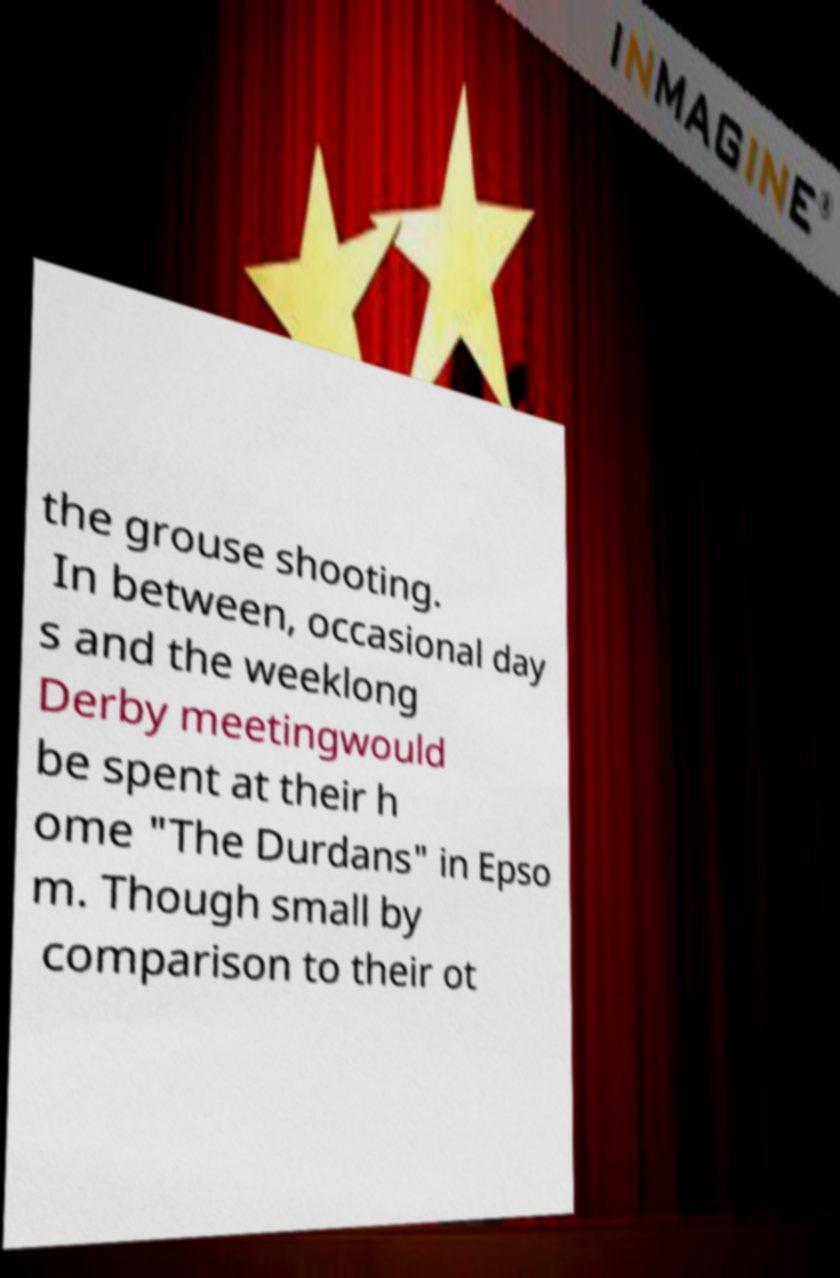I need the written content from this picture converted into text. Can you do that? the grouse shooting. In between, occasional day s and the weeklong Derby meetingwould be spent at their h ome "The Durdans" in Epso m. Though small by comparison to their ot 